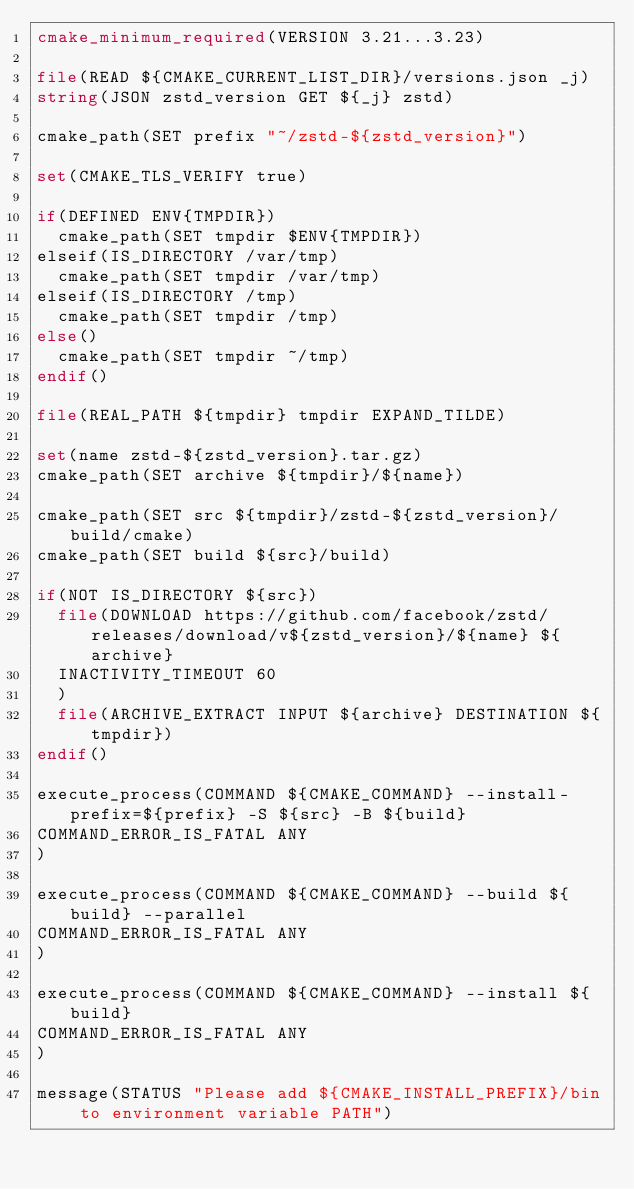<code> <loc_0><loc_0><loc_500><loc_500><_CMake_>cmake_minimum_required(VERSION 3.21...3.23)

file(READ ${CMAKE_CURRENT_LIST_DIR}/versions.json _j)
string(JSON zstd_version GET ${_j} zstd)

cmake_path(SET prefix "~/zstd-${zstd_version}")

set(CMAKE_TLS_VERIFY true)

if(DEFINED ENV{TMPDIR})
  cmake_path(SET tmpdir $ENV{TMPDIR})
elseif(IS_DIRECTORY /var/tmp)
  cmake_path(SET tmpdir /var/tmp)
elseif(IS_DIRECTORY /tmp)
  cmake_path(SET tmpdir /tmp)
else()
  cmake_path(SET tmpdir ~/tmp)
endif()

file(REAL_PATH ${tmpdir} tmpdir EXPAND_TILDE)

set(name zstd-${zstd_version}.tar.gz)
cmake_path(SET archive ${tmpdir}/${name})

cmake_path(SET src ${tmpdir}/zstd-${zstd_version}/build/cmake)
cmake_path(SET build ${src}/build)

if(NOT IS_DIRECTORY ${src})
  file(DOWNLOAD https://github.com/facebook/zstd/releases/download/v${zstd_version}/${name} ${archive}
  INACTIVITY_TIMEOUT 60
  )
  file(ARCHIVE_EXTRACT INPUT ${archive} DESTINATION ${tmpdir})
endif()

execute_process(COMMAND ${CMAKE_COMMAND} --install-prefix=${prefix} -S ${src} -B ${build}
COMMAND_ERROR_IS_FATAL ANY
)

execute_process(COMMAND ${CMAKE_COMMAND} --build ${build} --parallel
COMMAND_ERROR_IS_FATAL ANY
)

execute_process(COMMAND ${CMAKE_COMMAND} --install ${build}
COMMAND_ERROR_IS_FATAL ANY
)

message(STATUS "Please add ${CMAKE_INSTALL_PREFIX}/bin to environment variable PATH")
</code> 